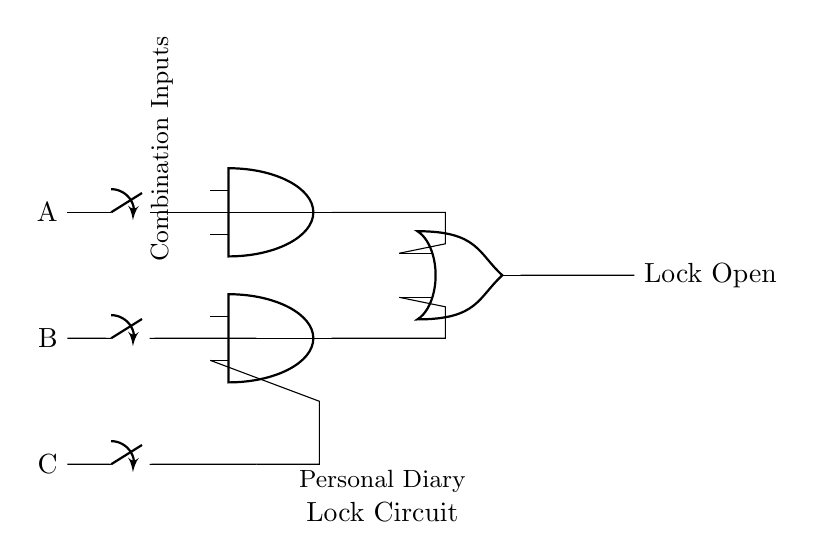What are the three inputs in the circuit? The inputs labeled on the left side of the circuit are A, B, and C. These identify the different switches used for entering combinations.
Answer: A, B, C What type of gate is used to combine inputs A and B? The circuit shows an AND gate connecting inputs A and B. An AND gate only outputs a high signal if all its inputs are high.
Answer: AND gate Which component outputs the lock status? The final output of the circuit, indicated as "Lock Open," is driven by an OR gate that summarizes the results of the AND gates.
Answer: Lock Open How many AND gates are present in the circuit? There are two AND gates depicted in the circuit, which handle combinations of the inputs for processing before the final output is determined.
Answer: Two What logic operation is represented by the circuit? The circuit represents a combination of AND and OR operations. Inputs A and B are processed through AND gates before their results are combined in an OR gate for the final output.
Answer: Combination of AND and OR If both A and B inputs are high but C is low, what will be the output of the circuit? With A and B high (1) and C low (0), only the AND gate connected to A and B will output high, while the output of the circuit will remain low since C does not meet the requirement for the AND gate connected to it.
Answer: Lock Closed 